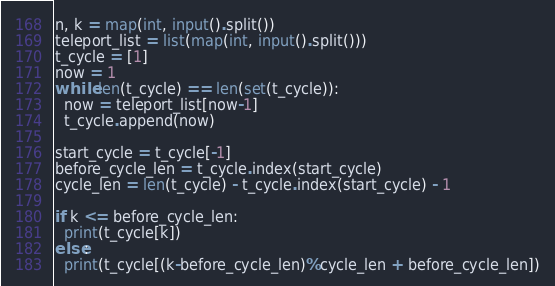<code> <loc_0><loc_0><loc_500><loc_500><_Python_>n, k = map(int, input().split())
teleport_list = list(map(int, input().split()))
t_cycle = [1]
now = 1
while len(t_cycle) == len(set(t_cycle)):
  now = teleport_list[now-1]
  t_cycle.append(now)

start_cycle = t_cycle[-1]
before_cycle_len = t_cycle.index(start_cycle)
cycle_len = len(t_cycle) - t_cycle.index(start_cycle) - 1

if k <= before_cycle_len:
  print(t_cycle[k])
else:
  print(t_cycle[(k-before_cycle_len)%cycle_len + before_cycle_len])</code> 